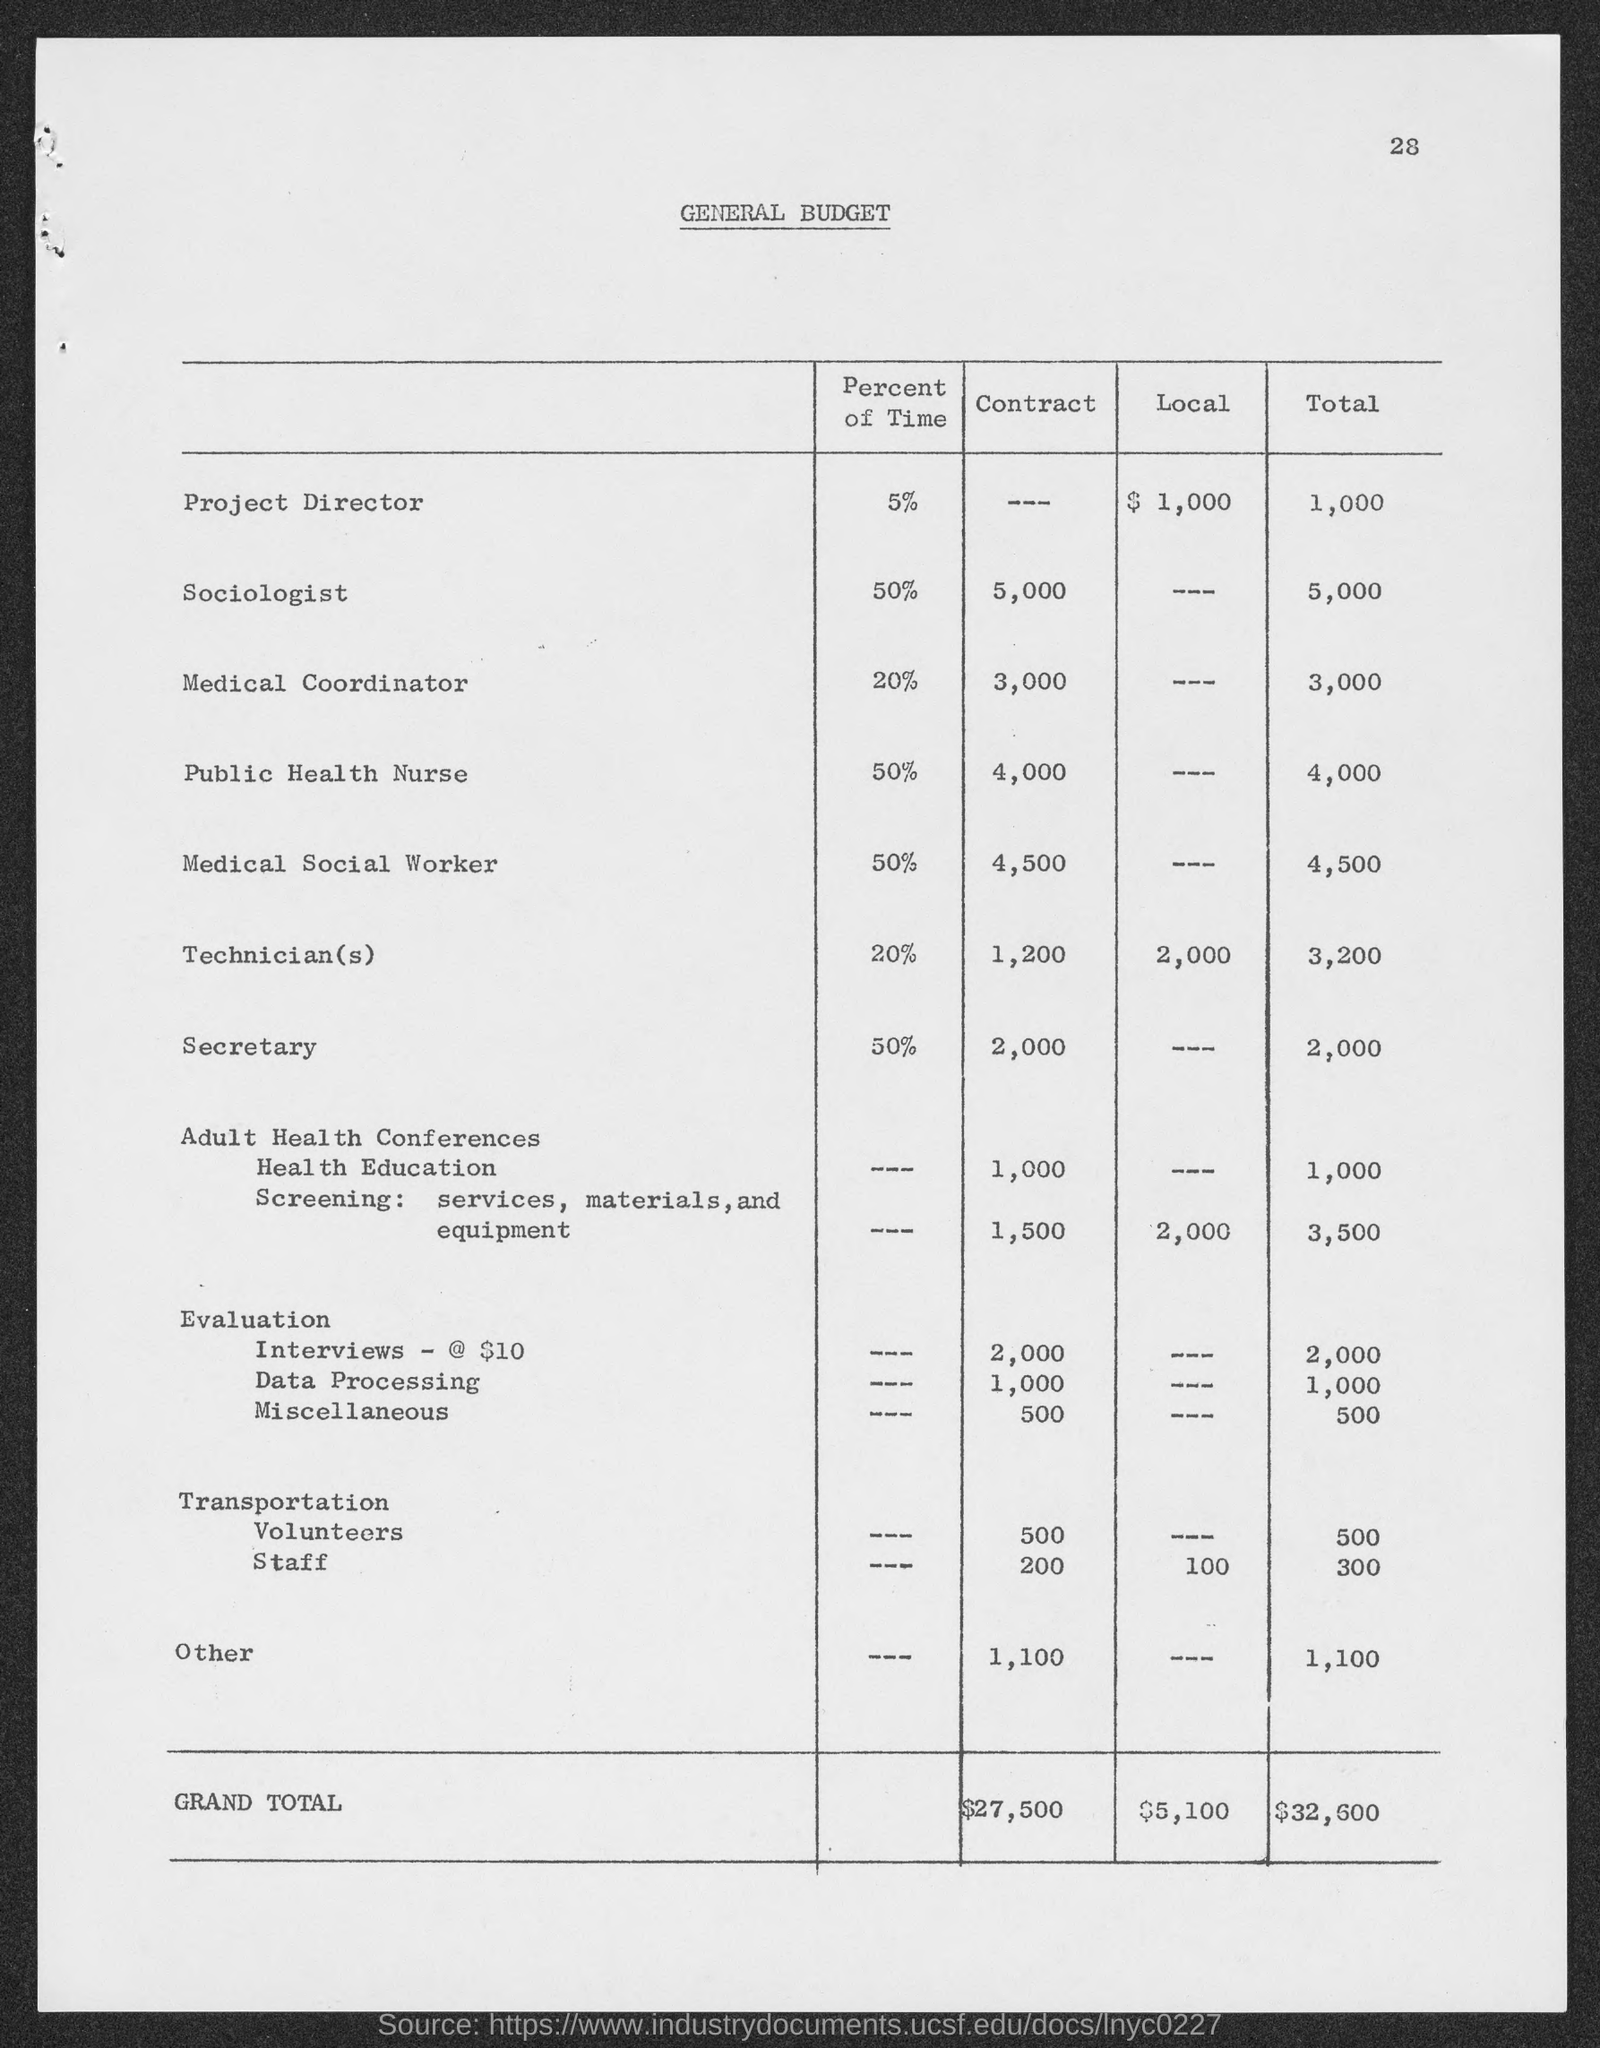what is the general budget total for Medical Coordinator?
 3,000 